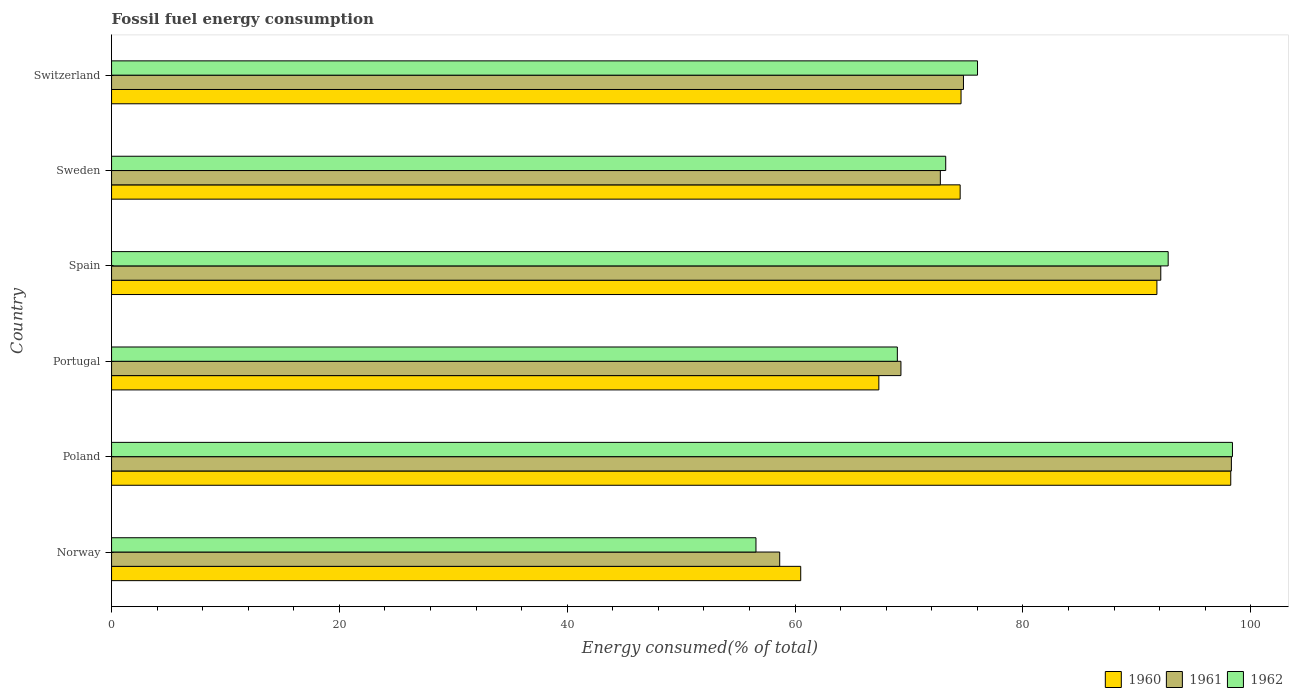How many bars are there on the 6th tick from the top?
Your answer should be very brief. 3. What is the label of the 4th group of bars from the top?
Offer a very short reply. Portugal. In how many cases, is the number of bars for a given country not equal to the number of legend labels?
Give a very brief answer. 0. What is the percentage of energy consumed in 1961 in Spain?
Your answer should be very brief. 92.1. Across all countries, what is the maximum percentage of energy consumed in 1962?
Offer a terse response. 98.4. Across all countries, what is the minimum percentage of energy consumed in 1961?
Keep it short and to the point. 58.65. What is the total percentage of energy consumed in 1961 in the graph?
Your answer should be compact. 465.89. What is the difference between the percentage of energy consumed in 1961 in Poland and that in Switzerland?
Offer a terse response. 23.52. What is the difference between the percentage of energy consumed in 1961 in Spain and the percentage of energy consumed in 1960 in Norway?
Provide a short and direct response. 31.61. What is the average percentage of energy consumed in 1960 per country?
Your answer should be compact. 77.82. What is the difference between the percentage of energy consumed in 1961 and percentage of energy consumed in 1962 in Switzerland?
Ensure brevity in your answer.  -1.23. What is the ratio of the percentage of energy consumed in 1962 in Portugal to that in Sweden?
Offer a terse response. 0.94. Is the difference between the percentage of energy consumed in 1961 in Norway and Sweden greater than the difference between the percentage of energy consumed in 1962 in Norway and Sweden?
Your response must be concise. Yes. What is the difference between the highest and the second highest percentage of energy consumed in 1962?
Give a very brief answer. 5.64. What is the difference between the highest and the lowest percentage of energy consumed in 1962?
Ensure brevity in your answer.  41.83. What does the 1st bar from the top in Spain represents?
Give a very brief answer. 1962. Is it the case that in every country, the sum of the percentage of energy consumed in 1960 and percentage of energy consumed in 1961 is greater than the percentage of energy consumed in 1962?
Your answer should be very brief. Yes. What is the difference between two consecutive major ticks on the X-axis?
Give a very brief answer. 20. Are the values on the major ticks of X-axis written in scientific E-notation?
Keep it short and to the point. No. Where does the legend appear in the graph?
Your response must be concise. Bottom right. What is the title of the graph?
Your answer should be very brief. Fossil fuel energy consumption. Does "2002" appear as one of the legend labels in the graph?
Provide a succinct answer. No. What is the label or title of the X-axis?
Provide a short and direct response. Energy consumed(% of total). What is the Energy consumed(% of total) of 1960 in Norway?
Your answer should be very brief. 60.5. What is the Energy consumed(% of total) in 1961 in Norway?
Ensure brevity in your answer.  58.65. What is the Energy consumed(% of total) in 1962 in Norway?
Your response must be concise. 56.57. What is the Energy consumed(% of total) of 1960 in Poland?
Provide a short and direct response. 98.25. What is the Energy consumed(% of total) of 1961 in Poland?
Make the answer very short. 98.3. What is the Energy consumed(% of total) of 1962 in Poland?
Offer a terse response. 98.4. What is the Energy consumed(% of total) of 1960 in Portugal?
Provide a short and direct response. 67.36. What is the Energy consumed(% of total) in 1961 in Portugal?
Your answer should be very brief. 69.3. What is the Energy consumed(% of total) in 1962 in Portugal?
Ensure brevity in your answer.  68.98. What is the Energy consumed(% of total) in 1960 in Spain?
Make the answer very short. 91.77. What is the Energy consumed(% of total) in 1961 in Spain?
Ensure brevity in your answer.  92.1. What is the Energy consumed(% of total) in 1962 in Spain?
Ensure brevity in your answer.  92.75. What is the Energy consumed(% of total) of 1960 in Sweden?
Keep it short and to the point. 74.49. What is the Energy consumed(% of total) in 1961 in Sweden?
Keep it short and to the point. 72.75. What is the Energy consumed(% of total) in 1962 in Sweden?
Offer a very short reply. 73.23. What is the Energy consumed(% of total) of 1960 in Switzerland?
Offer a very short reply. 74.57. What is the Energy consumed(% of total) of 1961 in Switzerland?
Your answer should be very brief. 74.78. What is the Energy consumed(% of total) of 1962 in Switzerland?
Offer a terse response. 76.02. Across all countries, what is the maximum Energy consumed(% of total) in 1960?
Provide a short and direct response. 98.25. Across all countries, what is the maximum Energy consumed(% of total) of 1961?
Provide a short and direct response. 98.3. Across all countries, what is the maximum Energy consumed(% of total) in 1962?
Offer a terse response. 98.4. Across all countries, what is the minimum Energy consumed(% of total) in 1960?
Provide a succinct answer. 60.5. Across all countries, what is the minimum Energy consumed(% of total) in 1961?
Provide a succinct answer. 58.65. Across all countries, what is the minimum Energy consumed(% of total) in 1962?
Your answer should be compact. 56.57. What is the total Energy consumed(% of total) in 1960 in the graph?
Your response must be concise. 466.93. What is the total Energy consumed(% of total) of 1961 in the graph?
Your answer should be very brief. 465.89. What is the total Energy consumed(% of total) of 1962 in the graph?
Offer a terse response. 465.94. What is the difference between the Energy consumed(% of total) in 1960 in Norway and that in Poland?
Ensure brevity in your answer.  -37.75. What is the difference between the Energy consumed(% of total) of 1961 in Norway and that in Poland?
Keep it short and to the point. -39.65. What is the difference between the Energy consumed(% of total) of 1962 in Norway and that in Poland?
Your response must be concise. -41.83. What is the difference between the Energy consumed(% of total) of 1960 in Norway and that in Portugal?
Keep it short and to the point. -6.86. What is the difference between the Energy consumed(% of total) of 1961 in Norway and that in Portugal?
Make the answer very short. -10.64. What is the difference between the Energy consumed(% of total) in 1962 in Norway and that in Portugal?
Make the answer very short. -12.41. What is the difference between the Energy consumed(% of total) in 1960 in Norway and that in Spain?
Keep it short and to the point. -31.27. What is the difference between the Energy consumed(% of total) in 1961 in Norway and that in Spain?
Provide a short and direct response. -33.45. What is the difference between the Energy consumed(% of total) in 1962 in Norway and that in Spain?
Your response must be concise. -36.18. What is the difference between the Energy consumed(% of total) of 1960 in Norway and that in Sweden?
Provide a succinct answer. -14. What is the difference between the Energy consumed(% of total) in 1961 in Norway and that in Sweden?
Offer a very short reply. -14.1. What is the difference between the Energy consumed(% of total) of 1962 in Norway and that in Sweden?
Your answer should be very brief. -16.66. What is the difference between the Energy consumed(% of total) of 1960 in Norway and that in Switzerland?
Make the answer very short. -14.07. What is the difference between the Energy consumed(% of total) in 1961 in Norway and that in Switzerland?
Offer a terse response. -16.13. What is the difference between the Energy consumed(% of total) of 1962 in Norway and that in Switzerland?
Offer a terse response. -19.45. What is the difference between the Energy consumed(% of total) in 1960 in Poland and that in Portugal?
Make the answer very short. 30.89. What is the difference between the Energy consumed(% of total) of 1961 in Poland and that in Portugal?
Keep it short and to the point. 29.01. What is the difference between the Energy consumed(% of total) in 1962 in Poland and that in Portugal?
Your response must be concise. 29.42. What is the difference between the Energy consumed(% of total) in 1960 in Poland and that in Spain?
Your answer should be very brief. 6.48. What is the difference between the Energy consumed(% of total) of 1961 in Poland and that in Spain?
Offer a very short reply. 6.2. What is the difference between the Energy consumed(% of total) of 1962 in Poland and that in Spain?
Ensure brevity in your answer.  5.64. What is the difference between the Energy consumed(% of total) in 1960 in Poland and that in Sweden?
Make the answer very short. 23.75. What is the difference between the Energy consumed(% of total) of 1961 in Poland and that in Sweden?
Provide a short and direct response. 25.55. What is the difference between the Energy consumed(% of total) of 1962 in Poland and that in Sweden?
Make the answer very short. 25.17. What is the difference between the Energy consumed(% of total) in 1960 in Poland and that in Switzerland?
Your answer should be compact. 23.67. What is the difference between the Energy consumed(% of total) of 1961 in Poland and that in Switzerland?
Provide a succinct answer. 23.52. What is the difference between the Energy consumed(% of total) in 1962 in Poland and that in Switzerland?
Your answer should be compact. 22.38. What is the difference between the Energy consumed(% of total) in 1960 in Portugal and that in Spain?
Your response must be concise. -24.41. What is the difference between the Energy consumed(% of total) of 1961 in Portugal and that in Spain?
Your response must be concise. -22.81. What is the difference between the Energy consumed(% of total) in 1962 in Portugal and that in Spain?
Your response must be concise. -23.77. What is the difference between the Energy consumed(% of total) in 1960 in Portugal and that in Sweden?
Provide a succinct answer. -7.14. What is the difference between the Energy consumed(% of total) of 1961 in Portugal and that in Sweden?
Make the answer very short. -3.46. What is the difference between the Energy consumed(% of total) in 1962 in Portugal and that in Sweden?
Provide a short and direct response. -4.25. What is the difference between the Energy consumed(% of total) of 1960 in Portugal and that in Switzerland?
Ensure brevity in your answer.  -7.22. What is the difference between the Energy consumed(% of total) of 1961 in Portugal and that in Switzerland?
Offer a terse response. -5.49. What is the difference between the Energy consumed(% of total) in 1962 in Portugal and that in Switzerland?
Keep it short and to the point. -7.04. What is the difference between the Energy consumed(% of total) of 1960 in Spain and that in Sweden?
Keep it short and to the point. 17.27. What is the difference between the Energy consumed(% of total) in 1961 in Spain and that in Sweden?
Provide a short and direct response. 19.35. What is the difference between the Energy consumed(% of total) of 1962 in Spain and that in Sweden?
Your answer should be compact. 19.53. What is the difference between the Energy consumed(% of total) in 1960 in Spain and that in Switzerland?
Your answer should be very brief. 17.19. What is the difference between the Energy consumed(% of total) of 1961 in Spain and that in Switzerland?
Your answer should be compact. 17.32. What is the difference between the Energy consumed(% of total) in 1962 in Spain and that in Switzerland?
Your answer should be very brief. 16.74. What is the difference between the Energy consumed(% of total) of 1960 in Sweden and that in Switzerland?
Your response must be concise. -0.08. What is the difference between the Energy consumed(% of total) of 1961 in Sweden and that in Switzerland?
Offer a terse response. -2.03. What is the difference between the Energy consumed(% of total) of 1962 in Sweden and that in Switzerland?
Keep it short and to the point. -2.79. What is the difference between the Energy consumed(% of total) of 1960 in Norway and the Energy consumed(% of total) of 1961 in Poland?
Provide a succinct answer. -37.81. What is the difference between the Energy consumed(% of total) of 1960 in Norway and the Energy consumed(% of total) of 1962 in Poland?
Make the answer very short. -37.9. What is the difference between the Energy consumed(% of total) in 1961 in Norway and the Energy consumed(% of total) in 1962 in Poland?
Provide a short and direct response. -39.74. What is the difference between the Energy consumed(% of total) of 1960 in Norway and the Energy consumed(% of total) of 1961 in Portugal?
Keep it short and to the point. -8.8. What is the difference between the Energy consumed(% of total) in 1960 in Norway and the Energy consumed(% of total) in 1962 in Portugal?
Provide a short and direct response. -8.48. What is the difference between the Energy consumed(% of total) of 1961 in Norway and the Energy consumed(% of total) of 1962 in Portugal?
Provide a short and direct response. -10.33. What is the difference between the Energy consumed(% of total) in 1960 in Norway and the Energy consumed(% of total) in 1961 in Spain?
Ensure brevity in your answer.  -31.61. What is the difference between the Energy consumed(% of total) in 1960 in Norway and the Energy consumed(% of total) in 1962 in Spain?
Give a very brief answer. -32.26. What is the difference between the Energy consumed(% of total) in 1961 in Norway and the Energy consumed(% of total) in 1962 in Spain?
Keep it short and to the point. -34.1. What is the difference between the Energy consumed(% of total) of 1960 in Norway and the Energy consumed(% of total) of 1961 in Sweden?
Provide a short and direct response. -12.26. What is the difference between the Energy consumed(% of total) of 1960 in Norway and the Energy consumed(% of total) of 1962 in Sweden?
Offer a terse response. -12.73. What is the difference between the Energy consumed(% of total) of 1961 in Norway and the Energy consumed(% of total) of 1962 in Sweden?
Your answer should be compact. -14.57. What is the difference between the Energy consumed(% of total) of 1960 in Norway and the Energy consumed(% of total) of 1961 in Switzerland?
Your answer should be very brief. -14.29. What is the difference between the Energy consumed(% of total) in 1960 in Norway and the Energy consumed(% of total) in 1962 in Switzerland?
Your answer should be compact. -15.52. What is the difference between the Energy consumed(% of total) in 1961 in Norway and the Energy consumed(% of total) in 1962 in Switzerland?
Offer a very short reply. -17.37. What is the difference between the Energy consumed(% of total) of 1960 in Poland and the Energy consumed(% of total) of 1961 in Portugal?
Ensure brevity in your answer.  28.95. What is the difference between the Energy consumed(% of total) in 1960 in Poland and the Energy consumed(% of total) in 1962 in Portugal?
Your response must be concise. 29.27. What is the difference between the Energy consumed(% of total) of 1961 in Poland and the Energy consumed(% of total) of 1962 in Portugal?
Your answer should be compact. 29.32. What is the difference between the Energy consumed(% of total) of 1960 in Poland and the Energy consumed(% of total) of 1961 in Spain?
Your answer should be very brief. 6.14. What is the difference between the Energy consumed(% of total) of 1960 in Poland and the Energy consumed(% of total) of 1962 in Spain?
Keep it short and to the point. 5.49. What is the difference between the Energy consumed(% of total) in 1961 in Poland and the Energy consumed(% of total) in 1962 in Spain?
Your answer should be very brief. 5.55. What is the difference between the Energy consumed(% of total) of 1960 in Poland and the Energy consumed(% of total) of 1961 in Sweden?
Your answer should be very brief. 25.49. What is the difference between the Energy consumed(% of total) in 1960 in Poland and the Energy consumed(% of total) in 1962 in Sweden?
Keep it short and to the point. 25.02. What is the difference between the Energy consumed(% of total) in 1961 in Poland and the Energy consumed(% of total) in 1962 in Sweden?
Ensure brevity in your answer.  25.08. What is the difference between the Energy consumed(% of total) in 1960 in Poland and the Energy consumed(% of total) in 1961 in Switzerland?
Offer a very short reply. 23.46. What is the difference between the Energy consumed(% of total) in 1960 in Poland and the Energy consumed(% of total) in 1962 in Switzerland?
Your answer should be very brief. 22.23. What is the difference between the Energy consumed(% of total) of 1961 in Poland and the Energy consumed(% of total) of 1962 in Switzerland?
Your response must be concise. 22.29. What is the difference between the Energy consumed(% of total) in 1960 in Portugal and the Energy consumed(% of total) in 1961 in Spain?
Offer a terse response. -24.75. What is the difference between the Energy consumed(% of total) in 1960 in Portugal and the Energy consumed(% of total) in 1962 in Spain?
Offer a terse response. -25.4. What is the difference between the Energy consumed(% of total) of 1961 in Portugal and the Energy consumed(% of total) of 1962 in Spain?
Make the answer very short. -23.46. What is the difference between the Energy consumed(% of total) of 1960 in Portugal and the Energy consumed(% of total) of 1961 in Sweden?
Your answer should be very brief. -5.4. What is the difference between the Energy consumed(% of total) in 1960 in Portugal and the Energy consumed(% of total) in 1962 in Sweden?
Your answer should be very brief. -5.87. What is the difference between the Energy consumed(% of total) of 1961 in Portugal and the Energy consumed(% of total) of 1962 in Sweden?
Your response must be concise. -3.93. What is the difference between the Energy consumed(% of total) of 1960 in Portugal and the Energy consumed(% of total) of 1961 in Switzerland?
Ensure brevity in your answer.  -7.43. What is the difference between the Energy consumed(% of total) in 1960 in Portugal and the Energy consumed(% of total) in 1962 in Switzerland?
Ensure brevity in your answer.  -8.66. What is the difference between the Energy consumed(% of total) in 1961 in Portugal and the Energy consumed(% of total) in 1962 in Switzerland?
Ensure brevity in your answer.  -6.72. What is the difference between the Energy consumed(% of total) of 1960 in Spain and the Energy consumed(% of total) of 1961 in Sweden?
Keep it short and to the point. 19.01. What is the difference between the Energy consumed(% of total) in 1960 in Spain and the Energy consumed(% of total) in 1962 in Sweden?
Give a very brief answer. 18.54. What is the difference between the Energy consumed(% of total) in 1961 in Spain and the Energy consumed(% of total) in 1962 in Sweden?
Keep it short and to the point. 18.88. What is the difference between the Energy consumed(% of total) in 1960 in Spain and the Energy consumed(% of total) in 1961 in Switzerland?
Keep it short and to the point. 16.98. What is the difference between the Energy consumed(% of total) in 1960 in Spain and the Energy consumed(% of total) in 1962 in Switzerland?
Offer a very short reply. 15.75. What is the difference between the Energy consumed(% of total) of 1961 in Spain and the Energy consumed(% of total) of 1962 in Switzerland?
Provide a succinct answer. 16.09. What is the difference between the Energy consumed(% of total) in 1960 in Sweden and the Energy consumed(% of total) in 1961 in Switzerland?
Provide a short and direct response. -0.29. What is the difference between the Energy consumed(% of total) in 1960 in Sweden and the Energy consumed(% of total) in 1962 in Switzerland?
Offer a very short reply. -1.52. What is the difference between the Energy consumed(% of total) of 1961 in Sweden and the Energy consumed(% of total) of 1962 in Switzerland?
Provide a succinct answer. -3.26. What is the average Energy consumed(% of total) of 1960 per country?
Your response must be concise. 77.82. What is the average Energy consumed(% of total) in 1961 per country?
Your answer should be very brief. 77.65. What is the average Energy consumed(% of total) of 1962 per country?
Give a very brief answer. 77.66. What is the difference between the Energy consumed(% of total) of 1960 and Energy consumed(% of total) of 1961 in Norway?
Make the answer very short. 1.85. What is the difference between the Energy consumed(% of total) in 1960 and Energy consumed(% of total) in 1962 in Norway?
Make the answer very short. 3.93. What is the difference between the Energy consumed(% of total) of 1961 and Energy consumed(% of total) of 1962 in Norway?
Provide a succinct answer. 2.08. What is the difference between the Energy consumed(% of total) in 1960 and Energy consumed(% of total) in 1961 in Poland?
Provide a short and direct response. -0.06. What is the difference between the Energy consumed(% of total) of 1960 and Energy consumed(% of total) of 1962 in Poland?
Keep it short and to the point. -0.15. What is the difference between the Energy consumed(% of total) of 1961 and Energy consumed(% of total) of 1962 in Poland?
Give a very brief answer. -0.09. What is the difference between the Energy consumed(% of total) of 1960 and Energy consumed(% of total) of 1961 in Portugal?
Your answer should be very brief. -1.94. What is the difference between the Energy consumed(% of total) of 1960 and Energy consumed(% of total) of 1962 in Portugal?
Your response must be concise. -1.62. What is the difference between the Energy consumed(% of total) in 1961 and Energy consumed(% of total) in 1962 in Portugal?
Offer a very short reply. 0.32. What is the difference between the Energy consumed(% of total) in 1960 and Energy consumed(% of total) in 1961 in Spain?
Keep it short and to the point. -0.34. What is the difference between the Energy consumed(% of total) of 1960 and Energy consumed(% of total) of 1962 in Spain?
Keep it short and to the point. -0.99. What is the difference between the Energy consumed(% of total) of 1961 and Energy consumed(% of total) of 1962 in Spain?
Provide a succinct answer. -0.65. What is the difference between the Energy consumed(% of total) in 1960 and Energy consumed(% of total) in 1961 in Sweden?
Your answer should be very brief. 1.74. What is the difference between the Energy consumed(% of total) of 1960 and Energy consumed(% of total) of 1962 in Sweden?
Offer a terse response. 1.27. What is the difference between the Energy consumed(% of total) of 1961 and Energy consumed(% of total) of 1962 in Sweden?
Your response must be concise. -0.47. What is the difference between the Energy consumed(% of total) of 1960 and Energy consumed(% of total) of 1961 in Switzerland?
Offer a very short reply. -0.21. What is the difference between the Energy consumed(% of total) in 1960 and Energy consumed(% of total) in 1962 in Switzerland?
Your response must be concise. -1.45. What is the difference between the Energy consumed(% of total) of 1961 and Energy consumed(% of total) of 1962 in Switzerland?
Offer a terse response. -1.23. What is the ratio of the Energy consumed(% of total) of 1960 in Norway to that in Poland?
Give a very brief answer. 0.62. What is the ratio of the Energy consumed(% of total) of 1961 in Norway to that in Poland?
Your answer should be very brief. 0.6. What is the ratio of the Energy consumed(% of total) in 1962 in Norway to that in Poland?
Your answer should be very brief. 0.57. What is the ratio of the Energy consumed(% of total) of 1960 in Norway to that in Portugal?
Your answer should be very brief. 0.9. What is the ratio of the Energy consumed(% of total) of 1961 in Norway to that in Portugal?
Provide a short and direct response. 0.85. What is the ratio of the Energy consumed(% of total) in 1962 in Norway to that in Portugal?
Offer a very short reply. 0.82. What is the ratio of the Energy consumed(% of total) of 1960 in Norway to that in Spain?
Offer a very short reply. 0.66. What is the ratio of the Energy consumed(% of total) of 1961 in Norway to that in Spain?
Offer a terse response. 0.64. What is the ratio of the Energy consumed(% of total) of 1962 in Norway to that in Spain?
Your answer should be compact. 0.61. What is the ratio of the Energy consumed(% of total) of 1960 in Norway to that in Sweden?
Provide a succinct answer. 0.81. What is the ratio of the Energy consumed(% of total) in 1961 in Norway to that in Sweden?
Offer a very short reply. 0.81. What is the ratio of the Energy consumed(% of total) in 1962 in Norway to that in Sweden?
Offer a very short reply. 0.77. What is the ratio of the Energy consumed(% of total) of 1960 in Norway to that in Switzerland?
Offer a terse response. 0.81. What is the ratio of the Energy consumed(% of total) in 1961 in Norway to that in Switzerland?
Provide a succinct answer. 0.78. What is the ratio of the Energy consumed(% of total) of 1962 in Norway to that in Switzerland?
Provide a short and direct response. 0.74. What is the ratio of the Energy consumed(% of total) in 1960 in Poland to that in Portugal?
Provide a succinct answer. 1.46. What is the ratio of the Energy consumed(% of total) of 1961 in Poland to that in Portugal?
Your response must be concise. 1.42. What is the ratio of the Energy consumed(% of total) of 1962 in Poland to that in Portugal?
Keep it short and to the point. 1.43. What is the ratio of the Energy consumed(% of total) of 1960 in Poland to that in Spain?
Your response must be concise. 1.07. What is the ratio of the Energy consumed(% of total) in 1961 in Poland to that in Spain?
Provide a succinct answer. 1.07. What is the ratio of the Energy consumed(% of total) of 1962 in Poland to that in Spain?
Your answer should be very brief. 1.06. What is the ratio of the Energy consumed(% of total) of 1960 in Poland to that in Sweden?
Your answer should be compact. 1.32. What is the ratio of the Energy consumed(% of total) of 1961 in Poland to that in Sweden?
Make the answer very short. 1.35. What is the ratio of the Energy consumed(% of total) of 1962 in Poland to that in Sweden?
Provide a succinct answer. 1.34. What is the ratio of the Energy consumed(% of total) in 1960 in Poland to that in Switzerland?
Ensure brevity in your answer.  1.32. What is the ratio of the Energy consumed(% of total) in 1961 in Poland to that in Switzerland?
Give a very brief answer. 1.31. What is the ratio of the Energy consumed(% of total) of 1962 in Poland to that in Switzerland?
Provide a succinct answer. 1.29. What is the ratio of the Energy consumed(% of total) of 1960 in Portugal to that in Spain?
Offer a very short reply. 0.73. What is the ratio of the Energy consumed(% of total) in 1961 in Portugal to that in Spain?
Your response must be concise. 0.75. What is the ratio of the Energy consumed(% of total) of 1962 in Portugal to that in Spain?
Ensure brevity in your answer.  0.74. What is the ratio of the Energy consumed(% of total) in 1960 in Portugal to that in Sweden?
Keep it short and to the point. 0.9. What is the ratio of the Energy consumed(% of total) of 1961 in Portugal to that in Sweden?
Keep it short and to the point. 0.95. What is the ratio of the Energy consumed(% of total) in 1962 in Portugal to that in Sweden?
Offer a terse response. 0.94. What is the ratio of the Energy consumed(% of total) of 1960 in Portugal to that in Switzerland?
Provide a short and direct response. 0.9. What is the ratio of the Energy consumed(% of total) in 1961 in Portugal to that in Switzerland?
Make the answer very short. 0.93. What is the ratio of the Energy consumed(% of total) of 1962 in Portugal to that in Switzerland?
Offer a very short reply. 0.91. What is the ratio of the Energy consumed(% of total) in 1960 in Spain to that in Sweden?
Provide a succinct answer. 1.23. What is the ratio of the Energy consumed(% of total) in 1961 in Spain to that in Sweden?
Your response must be concise. 1.27. What is the ratio of the Energy consumed(% of total) in 1962 in Spain to that in Sweden?
Make the answer very short. 1.27. What is the ratio of the Energy consumed(% of total) of 1960 in Spain to that in Switzerland?
Keep it short and to the point. 1.23. What is the ratio of the Energy consumed(% of total) in 1961 in Spain to that in Switzerland?
Ensure brevity in your answer.  1.23. What is the ratio of the Energy consumed(% of total) of 1962 in Spain to that in Switzerland?
Make the answer very short. 1.22. What is the ratio of the Energy consumed(% of total) of 1960 in Sweden to that in Switzerland?
Make the answer very short. 1. What is the ratio of the Energy consumed(% of total) in 1961 in Sweden to that in Switzerland?
Keep it short and to the point. 0.97. What is the ratio of the Energy consumed(% of total) in 1962 in Sweden to that in Switzerland?
Offer a terse response. 0.96. What is the difference between the highest and the second highest Energy consumed(% of total) of 1960?
Make the answer very short. 6.48. What is the difference between the highest and the second highest Energy consumed(% of total) in 1961?
Provide a short and direct response. 6.2. What is the difference between the highest and the second highest Energy consumed(% of total) in 1962?
Give a very brief answer. 5.64. What is the difference between the highest and the lowest Energy consumed(% of total) of 1960?
Provide a short and direct response. 37.75. What is the difference between the highest and the lowest Energy consumed(% of total) in 1961?
Provide a short and direct response. 39.65. What is the difference between the highest and the lowest Energy consumed(% of total) of 1962?
Give a very brief answer. 41.83. 